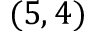Convert formula to latex. <formula><loc_0><loc_0><loc_500><loc_500>( 5 , 4 )</formula> 